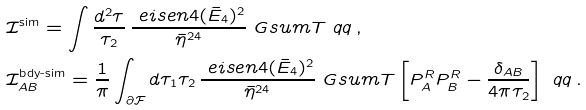Convert formula to latex. <formula><loc_0><loc_0><loc_500><loc_500>& \mathcal { I } ^ { \text {sim} } = \int \frac { d ^ { 2 } \tau } { \tau _ { 2 } } \, \frac { \ e i s e n { 4 } ( \bar { E } _ { 4 } ) ^ { 2 } } { \bar { \eta } ^ { 2 4 } } \ G s u m T \ q q \, , \\ & \mathcal { I } ^ { \text {bdy-sim} } _ { A B } = \frac { 1 } { \pi } \int _ { \partial \mathcal { F } } d \tau _ { 1 } \tau _ { 2 } \, \frac { \ e i s e n { 4 } ( \bar { E } _ { 4 } ) ^ { 2 } } { \bar { \eta } ^ { 2 4 } } \ G s u m T \left [ P ^ { R } _ { A } P _ { B } ^ { R } - \frac { \delta _ { A B } } { 4 \pi \tau _ { 2 } } \right ] \ q q \, .</formula> 